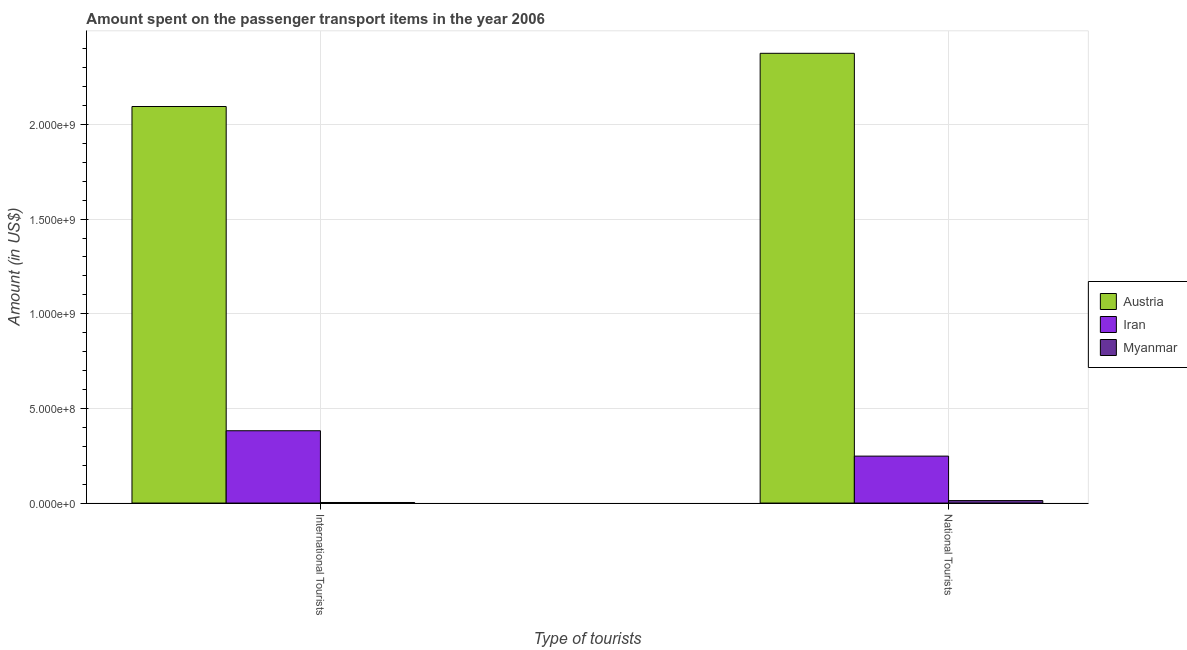How many groups of bars are there?
Ensure brevity in your answer.  2. What is the label of the 2nd group of bars from the left?
Your response must be concise. National Tourists. What is the amount spent on transport items of national tourists in Austria?
Keep it short and to the point. 2.38e+09. Across all countries, what is the maximum amount spent on transport items of international tourists?
Offer a very short reply. 2.10e+09. Across all countries, what is the minimum amount spent on transport items of international tourists?
Your response must be concise. 3.00e+06. In which country was the amount spent on transport items of national tourists maximum?
Offer a very short reply. Austria. In which country was the amount spent on transport items of national tourists minimum?
Make the answer very short. Myanmar. What is the total amount spent on transport items of national tourists in the graph?
Offer a terse response. 2.64e+09. What is the difference between the amount spent on transport items of international tourists in Myanmar and that in Austria?
Offer a very short reply. -2.09e+09. What is the difference between the amount spent on transport items of international tourists in Iran and the amount spent on transport items of national tourists in Austria?
Provide a short and direct response. -1.99e+09. What is the average amount spent on transport items of international tourists per country?
Your response must be concise. 8.27e+08. What is the difference between the amount spent on transport items of national tourists and amount spent on transport items of international tourists in Austria?
Your response must be concise. 2.81e+08. What is the ratio of the amount spent on transport items of international tourists in Iran to that in Myanmar?
Offer a very short reply. 127.33. What does the 3rd bar from the left in International Tourists represents?
Your response must be concise. Myanmar. How many bars are there?
Provide a short and direct response. 6. How many countries are there in the graph?
Give a very brief answer. 3. Are the values on the major ticks of Y-axis written in scientific E-notation?
Your answer should be compact. Yes. Does the graph contain any zero values?
Make the answer very short. No. Does the graph contain grids?
Ensure brevity in your answer.  Yes. What is the title of the graph?
Your response must be concise. Amount spent on the passenger transport items in the year 2006. Does "Palau" appear as one of the legend labels in the graph?
Your answer should be compact. No. What is the label or title of the X-axis?
Provide a short and direct response. Type of tourists. What is the Amount (in US$) of Austria in International Tourists?
Your answer should be very brief. 2.10e+09. What is the Amount (in US$) in Iran in International Tourists?
Provide a succinct answer. 3.82e+08. What is the Amount (in US$) in Austria in National Tourists?
Offer a terse response. 2.38e+09. What is the Amount (in US$) of Iran in National Tourists?
Your answer should be very brief. 2.48e+08. What is the Amount (in US$) in Myanmar in National Tourists?
Offer a terse response. 1.30e+07. Across all Type of tourists, what is the maximum Amount (in US$) of Austria?
Offer a very short reply. 2.38e+09. Across all Type of tourists, what is the maximum Amount (in US$) of Iran?
Give a very brief answer. 3.82e+08. Across all Type of tourists, what is the maximum Amount (in US$) in Myanmar?
Provide a succinct answer. 1.30e+07. Across all Type of tourists, what is the minimum Amount (in US$) of Austria?
Your answer should be very brief. 2.10e+09. Across all Type of tourists, what is the minimum Amount (in US$) of Iran?
Keep it short and to the point. 2.48e+08. Across all Type of tourists, what is the minimum Amount (in US$) of Myanmar?
Offer a very short reply. 3.00e+06. What is the total Amount (in US$) in Austria in the graph?
Make the answer very short. 4.47e+09. What is the total Amount (in US$) in Iran in the graph?
Provide a succinct answer. 6.30e+08. What is the total Amount (in US$) of Myanmar in the graph?
Offer a terse response. 1.60e+07. What is the difference between the Amount (in US$) of Austria in International Tourists and that in National Tourists?
Your answer should be compact. -2.81e+08. What is the difference between the Amount (in US$) of Iran in International Tourists and that in National Tourists?
Offer a terse response. 1.34e+08. What is the difference between the Amount (in US$) of Myanmar in International Tourists and that in National Tourists?
Make the answer very short. -1.00e+07. What is the difference between the Amount (in US$) in Austria in International Tourists and the Amount (in US$) in Iran in National Tourists?
Your response must be concise. 1.85e+09. What is the difference between the Amount (in US$) of Austria in International Tourists and the Amount (in US$) of Myanmar in National Tourists?
Offer a very short reply. 2.08e+09. What is the difference between the Amount (in US$) of Iran in International Tourists and the Amount (in US$) of Myanmar in National Tourists?
Provide a succinct answer. 3.69e+08. What is the average Amount (in US$) in Austria per Type of tourists?
Provide a succinct answer. 2.24e+09. What is the average Amount (in US$) in Iran per Type of tourists?
Offer a very short reply. 3.15e+08. What is the difference between the Amount (in US$) in Austria and Amount (in US$) in Iran in International Tourists?
Your answer should be compact. 1.71e+09. What is the difference between the Amount (in US$) of Austria and Amount (in US$) of Myanmar in International Tourists?
Ensure brevity in your answer.  2.09e+09. What is the difference between the Amount (in US$) of Iran and Amount (in US$) of Myanmar in International Tourists?
Keep it short and to the point. 3.79e+08. What is the difference between the Amount (in US$) in Austria and Amount (in US$) in Iran in National Tourists?
Make the answer very short. 2.13e+09. What is the difference between the Amount (in US$) in Austria and Amount (in US$) in Myanmar in National Tourists?
Your answer should be very brief. 2.36e+09. What is the difference between the Amount (in US$) in Iran and Amount (in US$) in Myanmar in National Tourists?
Your answer should be compact. 2.35e+08. What is the ratio of the Amount (in US$) of Austria in International Tourists to that in National Tourists?
Provide a succinct answer. 0.88. What is the ratio of the Amount (in US$) in Iran in International Tourists to that in National Tourists?
Ensure brevity in your answer.  1.54. What is the ratio of the Amount (in US$) of Myanmar in International Tourists to that in National Tourists?
Your response must be concise. 0.23. What is the difference between the highest and the second highest Amount (in US$) of Austria?
Give a very brief answer. 2.81e+08. What is the difference between the highest and the second highest Amount (in US$) of Iran?
Offer a terse response. 1.34e+08. What is the difference between the highest and the lowest Amount (in US$) in Austria?
Keep it short and to the point. 2.81e+08. What is the difference between the highest and the lowest Amount (in US$) of Iran?
Your response must be concise. 1.34e+08. What is the difference between the highest and the lowest Amount (in US$) of Myanmar?
Your answer should be compact. 1.00e+07. 